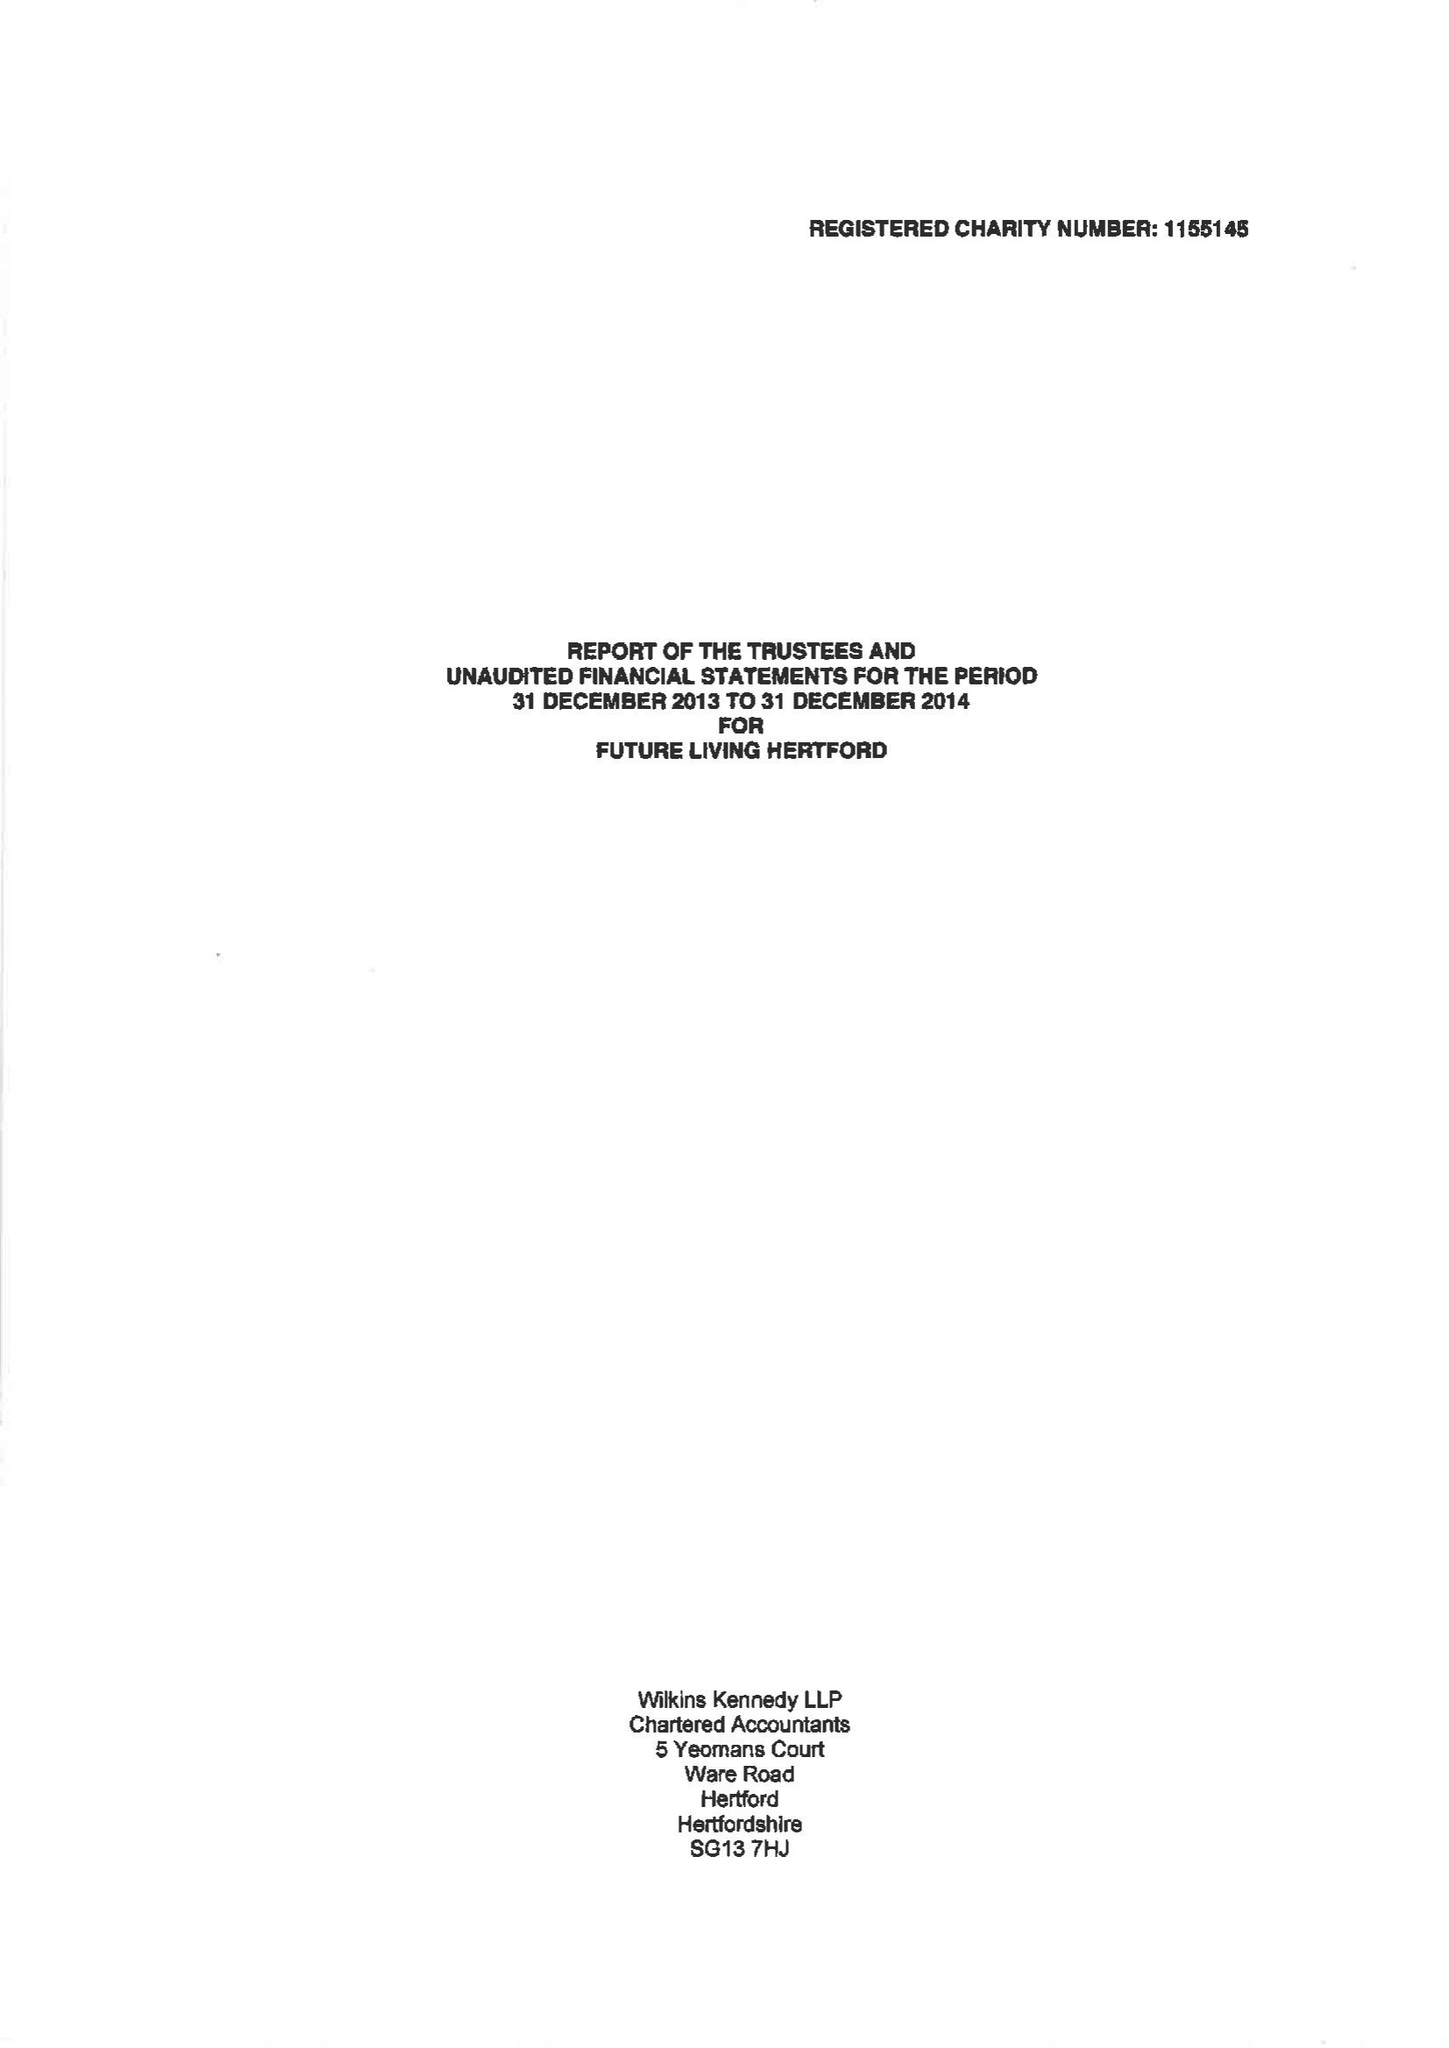What is the value for the charity_number?
Answer the question using a single word or phrase. 1155145 